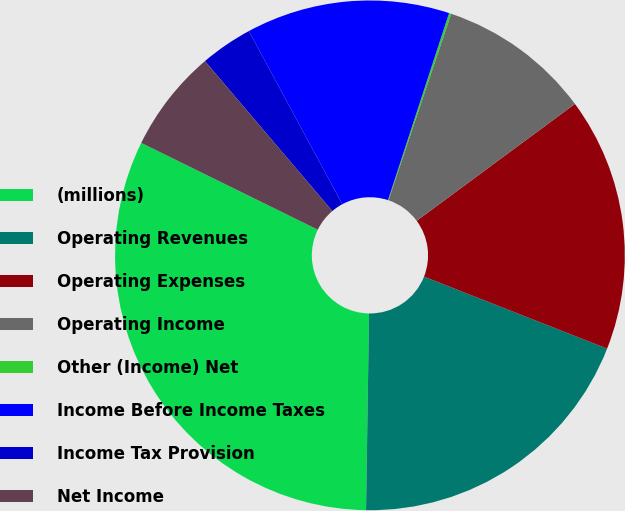Convert chart. <chart><loc_0><loc_0><loc_500><loc_500><pie_chart><fcel>(millions)<fcel>Operating Revenues<fcel>Operating Expenses<fcel>Operating Income<fcel>Other (Income) Net<fcel>Income Before Income Taxes<fcel>Income Tax Provision<fcel>Net Income<nl><fcel>32.03%<fcel>19.28%<fcel>16.09%<fcel>9.71%<fcel>0.14%<fcel>12.9%<fcel>3.33%<fcel>6.52%<nl></chart> 